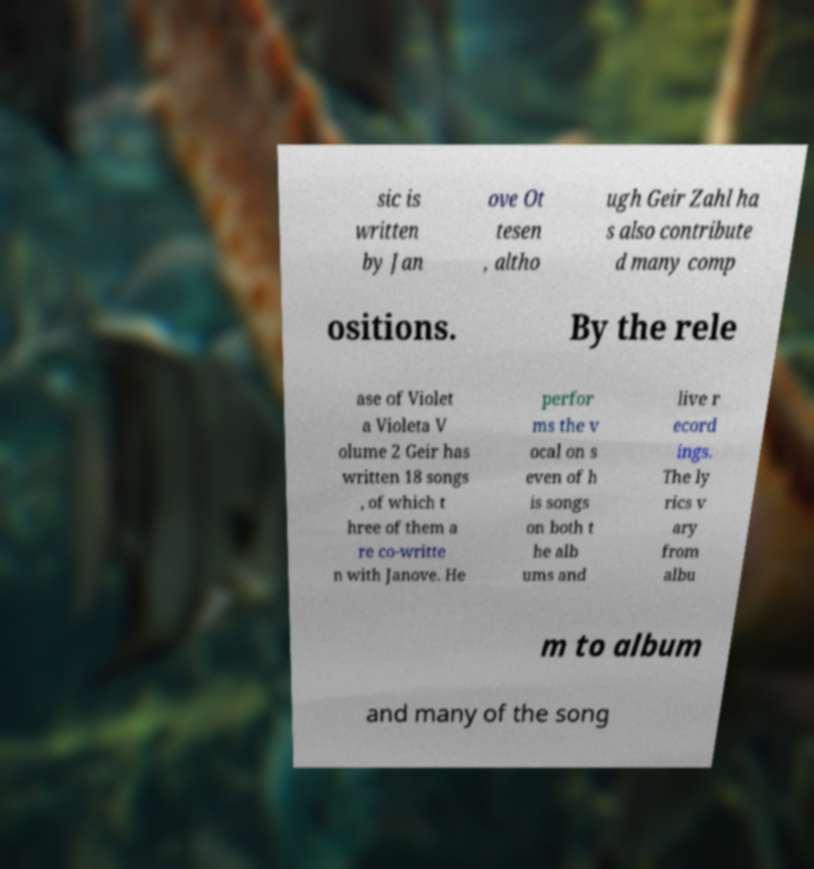There's text embedded in this image that I need extracted. Can you transcribe it verbatim? sic is written by Jan ove Ot tesen , altho ugh Geir Zahl ha s also contribute d many comp ositions. By the rele ase of Violet a Violeta V olume 2 Geir has written 18 songs , of which t hree of them a re co-writte n with Janove. He perfor ms the v ocal on s even of h is songs on both t he alb ums and live r ecord ings. The ly rics v ary from albu m to album and many of the song 